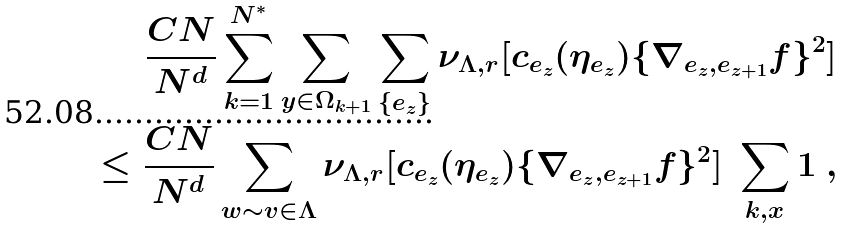<formula> <loc_0><loc_0><loc_500><loc_500>\frac { C N } { N ^ { d } } \sum _ { k = 1 } ^ { N ^ { * } } \sum _ { y \in \Omega _ { k + 1 } } \sum _ { \{ e _ { z } \} } \nu _ { \Lambda , r } [ c _ { e _ { z } } ( \eta _ { e _ { z } } ) \{ \nabla _ { e _ { z } , e _ { z + 1 } } f \} ^ { 2 } ] \\ \leq \frac { C N } { N ^ { d } } \sum _ { w \sim v \in \Lambda } \nu _ { \Lambda , r } [ c _ { e _ { z } } ( \eta _ { e _ { z } } ) \{ \nabla _ { e _ { z } , e _ { z + 1 } } f \} ^ { 2 } ] \ \sum _ { k , x } 1 \ ,</formula> 